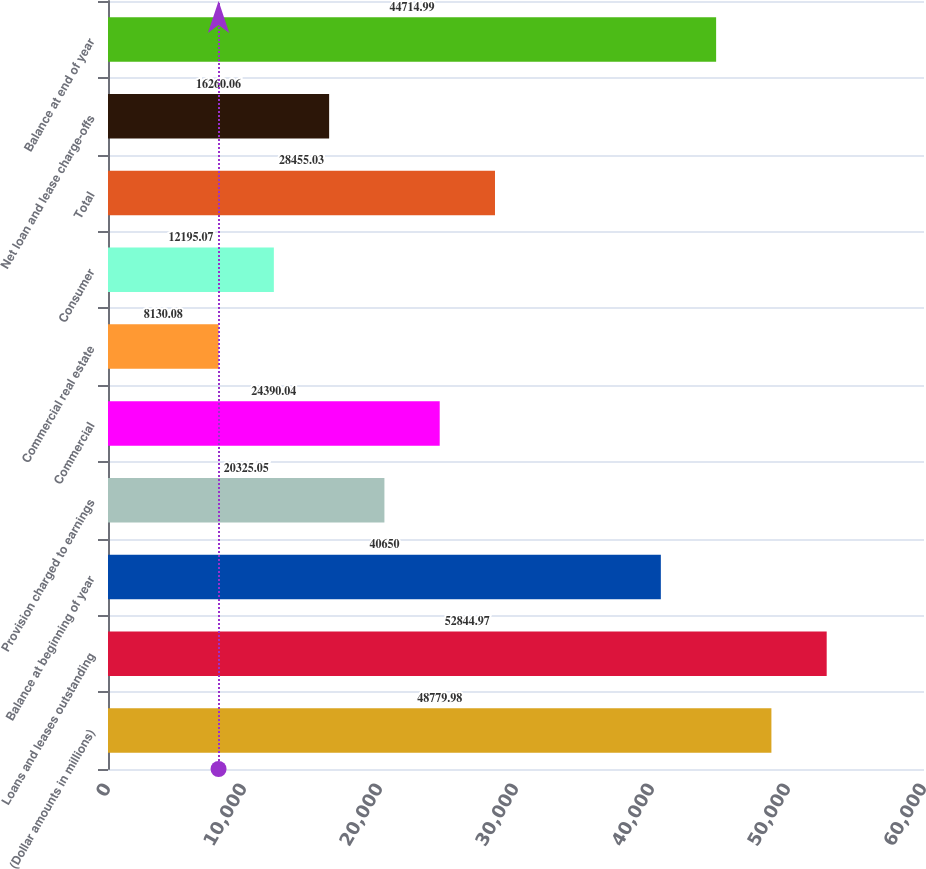Convert chart to OTSL. <chart><loc_0><loc_0><loc_500><loc_500><bar_chart><fcel>(Dollar amounts in millions)<fcel>Loans and leases outstanding<fcel>Balance at beginning of year<fcel>Provision charged to earnings<fcel>Commercial<fcel>Commercial real estate<fcel>Consumer<fcel>Total<fcel>Net loan and lease charge-offs<fcel>Balance at end of year<nl><fcel>48780<fcel>52845<fcel>40650<fcel>20325<fcel>24390<fcel>8130.08<fcel>12195.1<fcel>28455<fcel>16260.1<fcel>44715<nl></chart> 